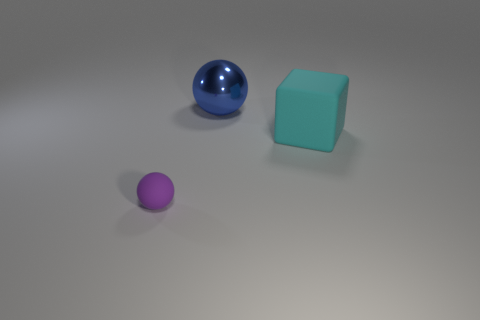Can you describe the spatial arrangement of the objects in the image? The objects are arranged with the large blue metallic sphere on the left, followed by a medium-sized purple sphere, and then the large cyan cube on the right. This arrangement creates a diagonal line that leads the viewer's eye across the scene. 